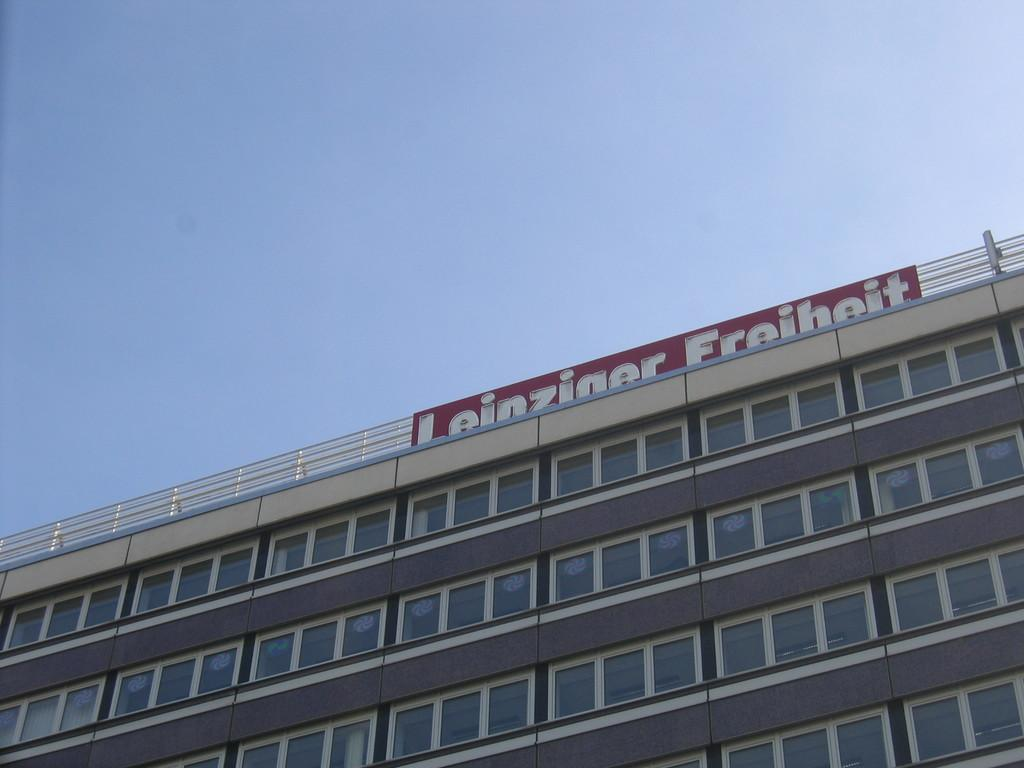What type of structure is visible in the image? There is a building in the image. What is attached to the building? There is a board on the building. What can be read on the board? There is text on the board. What is visible at the top of the image? The sky is visible at the top of the image. What can be seen inside the building? There are lights inside the building. How many oranges are being transported in the vessel shown in the image? There is no vessel or oranges present in the image. Is there a fight happening in the image? There is no fight depicted in the image. 